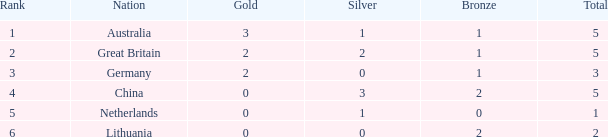How many total show when silver is 0, bronze is 1, and the rank is less than 3? 0.0. 